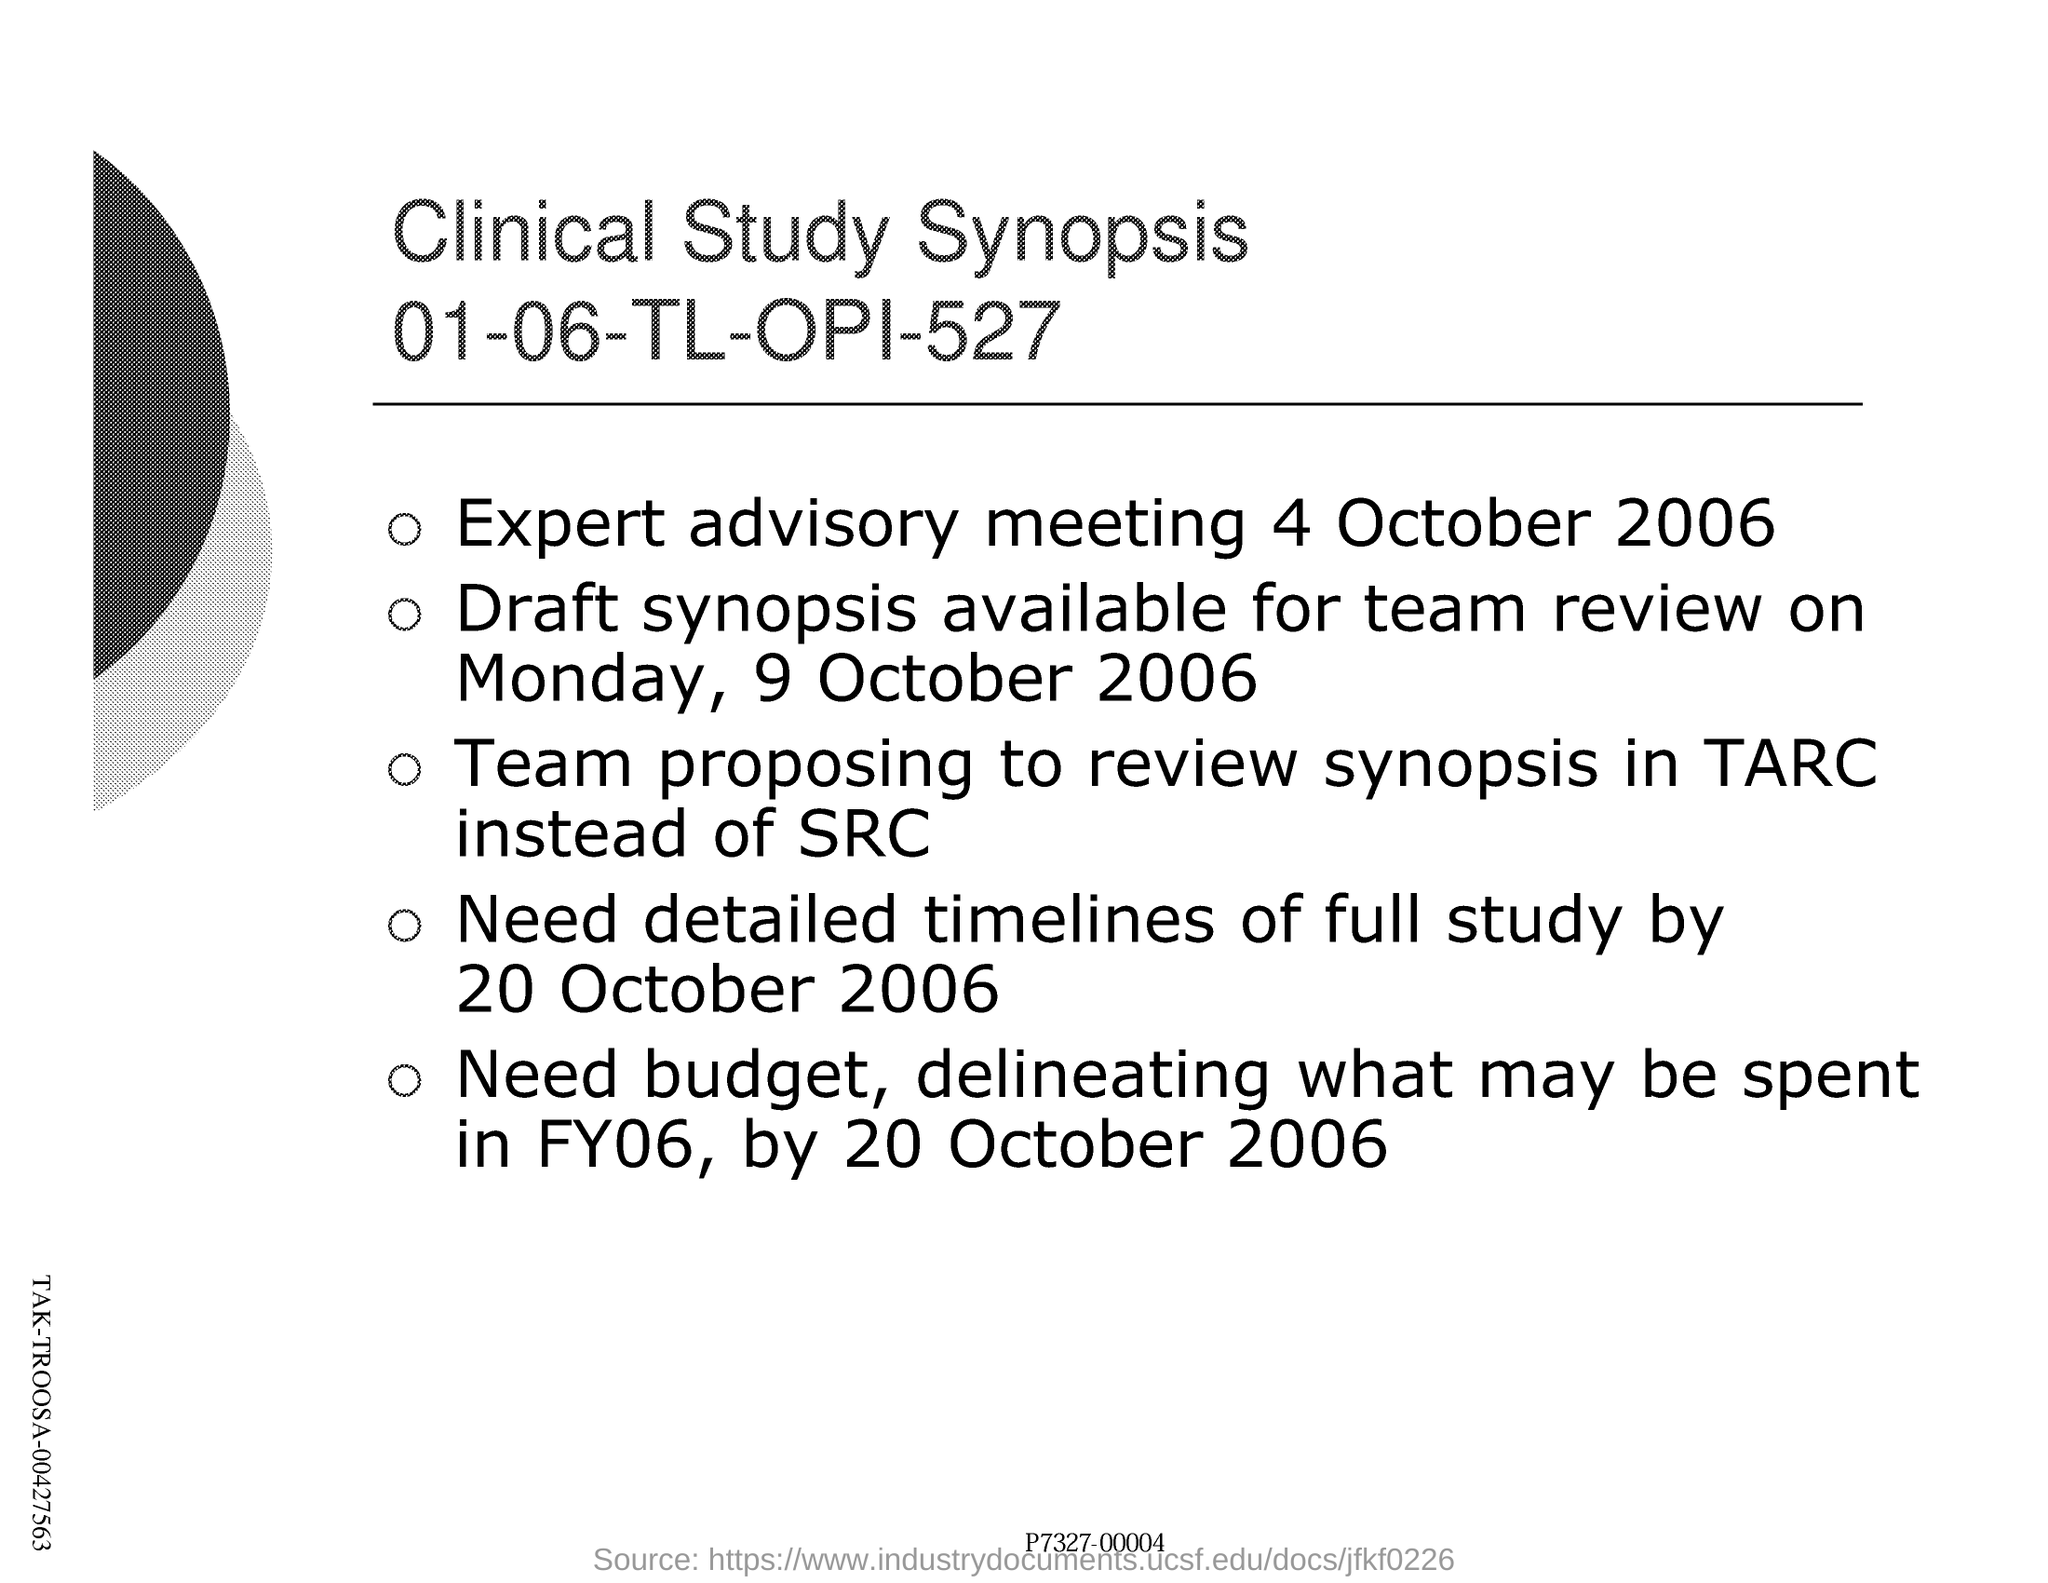Which study's synopsis is this?
Keep it short and to the point. Clinical Study. What is the code mentioned under the title of clinical study synopsis?
Your answer should be very brief. 01-06-TL-OPI-527. When was expert advisory meeting ?
Offer a very short reply. 4 october 2006. 